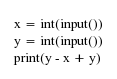<code> <loc_0><loc_0><loc_500><loc_500><_Python_>x = int(input())
y = int(input())
print(y - x + y)
</code> 